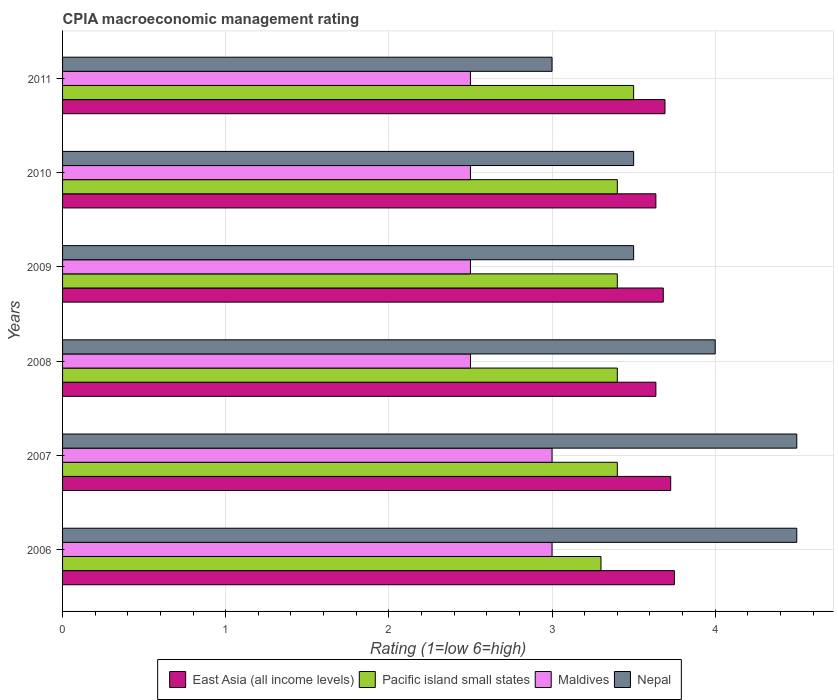How many different coloured bars are there?
Make the answer very short. 4. What is the label of the 4th group of bars from the top?
Provide a short and direct response. 2008. In how many cases, is the number of bars for a given year not equal to the number of legend labels?
Provide a succinct answer. 0. What is the CPIA rating in Nepal in 2008?
Give a very brief answer. 4. Across all years, what is the minimum CPIA rating in East Asia (all income levels)?
Your response must be concise. 3.64. In which year was the CPIA rating in East Asia (all income levels) minimum?
Offer a very short reply. 2008. What is the total CPIA rating in Pacific island small states in the graph?
Keep it short and to the point. 20.4. What is the difference between the CPIA rating in Pacific island small states in 2007 and that in 2008?
Ensure brevity in your answer.  0. What is the difference between the CPIA rating in Pacific island small states in 2009 and the CPIA rating in Maldives in 2008?
Offer a very short reply. 0.9. What is the average CPIA rating in East Asia (all income levels) per year?
Your answer should be compact. 3.69. In the year 2009, what is the difference between the CPIA rating in Nepal and CPIA rating in East Asia (all income levels)?
Your response must be concise. -0.18. In how many years, is the CPIA rating in Maldives greater than 3 ?
Make the answer very short. 0. What is the ratio of the CPIA rating in Nepal in 2008 to that in 2009?
Make the answer very short. 1.14. Is the difference between the CPIA rating in Nepal in 2007 and 2010 greater than the difference between the CPIA rating in East Asia (all income levels) in 2007 and 2010?
Your answer should be very brief. Yes. What is the difference between the highest and the second highest CPIA rating in Nepal?
Your answer should be very brief. 0. In how many years, is the CPIA rating in Maldives greater than the average CPIA rating in Maldives taken over all years?
Offer a terse response. 2. Is the sum of the CPIA rating in Nepal in 2006 and 2007 greater than the maximum CPIA rating in East Asia (all income levels) across all years?
Offer a very short reply. Yes. Is it the case that in every year, the sum of the CPIA rating in Maldives and CPIA rating in Nepal is greater than the sum of CPIA rating in Pacific island small states and CPIA rating in East Asia (all income levels)?
Provide a short and direct response. No. What does the 3rd bar from the top in 2010 represents?
Your answer should be compact. Pacific island small states. What does the 4th bar from the bottom in 2010 represents?
Provide a succinct answer. Nepal. How many bars are there?
Make the answer very short. 24. How many years are there in the graph?
Offer a very short reply. 6. What is the difference between two consecutive major ticks on the X-axis?
Make the answer very short. 1. Are the values on the major ticks of X-axis written in scientific E-notation?
Provide a succinct answer. No. Does the graph contain grids?
Provide a short and direct response. Yes. How are the legend labels stacked?
Keep it short and to the point. Horizontal. What is the title of the graph?
Offer a terse response. CPIA macroeconomic management rating. Does "Montenegro" appear as one of the legend labels in the graph?
Provide a succinct answer. No. What is the label or title of the Y-axis?
Your response must be concise. Years. What is the Rating (1=low 6=high) of East Asia (all income levels) in 2006?
Make the answer very short. 3.75. What is the Rating (1=low 6=high) of Pacific island small states in 2006?
Your answer should be compact. 3.3. What is the Rating (1=low 6=high) in East Asia (all income levels) in 2007?
Offer a terse response. 3.73. What is the Rating (1=low 6=high) in Pacific island small states in 2007?
Give a very brief answer. 3.4. What is the Rating (1=low 6=high) in Maldives in 2007?
Make the answer very short. 3. What is the Rating (1=low 6=high) of East Asia (all income levels) in 2008?
Provide a short and direct response. 3.64. What is the Rating (1=low 6=high) of Pacific island small states in 2008?
Offer a very short reply. 3.4. What is the Rating (1=low 6=high) in Maldives in 2008?
Your answer should be compact. 2.5. What is the Rating (1=low 6=high) of East Asia (all income levels) in 2009?
Give a very brief answer. 3.68. What is the Rating (1=low 6=high) in Pacific island small states in 2009?
Offer a terse response. 3.4. What is the Rating (1=low 6=high) of East Asia (all income levels) in 2010?
Your response must be concise. 3.64. What is the Rating (1=low 6=high) of Pacific island small states in 2010?
Give a very brief answer. 3.4. What is the Rating (1=low 6=high) of Nepal in 2010?
Make the answer very short. 3.5. What is the Rating (1=low 6=high) of East Asia (all income levels) in 2011?
Give a very brief answer. 3.69. What is the Rating (1=low 6=high) in Pacific island small states in 2011?
Ensure brevity in your answer.  3.5. What is the Rating (1=low 6=high) of Nepal in 2011?
Offer a terse response. 3. Across all years, what is the maximum Rating (1=low 6=high) in East Asia (all income levels)?
Your answer should be very brief. 3.75. Across all years, what is the maximum Rating (1=low 6=high) of Maldives?
Provide a short and direct response. 3. Across all years, what is the maximum Rating (1=low 6=high) of Nepal?
Ensure brevity in your answer.  4.5. Across all years, what is the minimum Rating (1=low 6=high) in East Asia (all income levels)?
Ensure brevity in your answer.  3.64. Across all years, what is the minimum Rating (1=low 6=high) of Pacific island small states?
Give a very brief answer. 3.3. Across all years, what is the minimum Rating (1=low 6=high) of Nepal?
Ensure brevity in your answer.  3. What is the total Rating (1=low 6=high) in East Asia (all income levels) in the graph?
Give a very brief answer. 22.12. What is the total Rating (1=low 6=high) in Pacific island small states in the graph?
Offer a very short reply. 20.4. What is the total Rating (1=low 6=high) in Maldives in the graph?
Your response must be concise. 16. What is the total Rating (1=low 6=high) in Nepal in the graph?
Provide a succinct answer. 23. What is the difference between the Rating (1=low 6=high) of East Asia (all income levels) in 2006 and that in 2007?
Keep it short and to the point. 0.02. What is the difference between the Rating (1=low 6=high) in East Asia (all income levels) in 2006 and that in 2008?
Your answer should be very brief. 0.11. What is the difference between the Rating (1=low 6=high) in Maldives in 2006 and that in 2008?
Provide a short and direct response. 0.5. What is the difference between the Rating (1=low 6=high) in East Asia (all income levels) in 2006 and that in 2009?
Make the answer very short. 0.07. What is the difference between the Rating (1=low 6=high) in Nepal in 2006 and that in 2009?
Provide a short and direct response. 1. What is the difference between the Rating (1=low 6=high) of East Asia (all income levels) in 2006 and that in 2010?
Give a very brief answer. 0.11. What is the difference between the Rating (1=low 6=high) in Pacific island small states in 2006 and that in 2010?
Your answer should be very brief. -0.1. What is the difference between the Rating (1=low 6=high) in East Asia (all income levels) in 2006 and that in 2011?
Make the answer very short. 0.06. What is the difference between the Rating (1=low 6=high) in Maldives in 2006 and that in 2011?
Your answer should be very brief. 0.5. What is the difference between the Rating (1=low 6=high) of Nepal in 2006 and that in 2011?
Offer a very short reply. 1.5. What is the difference between the Rating (1=low 6=high) in East Asia (all income levels) in 2007 and that in 2008?
Give a very brief answer. 0.09. What is the difference between the Rating (1=low 6=high) of Pacific island small states in 2007 and that in 2008?
Provide a short and direct response. 0. What is the difference between the Rating (1=low 6=high) in Maldives in 2007 and that in 2008?
Your answer should be compact. 0.5. What is the difference between the Rating (1=low 6=high) in Nepal in 2007 and that in 2008?
Ensure brevity in your answer.  0.5. What is the difference between the Rating (1=low 6=high) of East Asia (all income levels) in 2007 and that in 2009?
Offer a very short reply. 0.05. What is the difference between the Rating (1=low 6=high) in Pacific island small states in 2007 and that in 2009?
Ensure brevity in your answer.  0. What is the difference between the Rating (1=low 6=high) in East Asia (all income levels) in 2007 and that in 2010?
Your response must be concise. 0.09. What is the difference between the Rating (1=low 6=high) in Pacific island small states in 2007 and that in 2010?
Ensure brevity in your answer.  0. What is the difference between the Rating (1=low 6=high) in Nepal in 2007 and that in 2010?
Your answer should be very brief. 1. What is the difference between the Rating (1=low 6=high) in East Asia (all income levels) in 2007 and that in 2011?
Your answer should be compact. 0.04. What is the difference between the Rating (1=low 6=high) in Pacific island small states in 2007 and that in 2011?
Give a very brief answer. -0.1. What is the difference between the Rating (1=low 6=high) of Nepal in 2007 and that in 2011?
Make the answer very short. 1.5. What is the difference between the Rating (1=low 6=high) of East Asia (all income levels) in 2008 and that in 2009?
Provide a succinct answer. -0.05. What is the difference between the Rating (1=low 6=high) in Pacific island small states in 2008 and that in 2009?
Your answer should be compact. 0. What is the difference between the Rating (1=low 6=high) in Nepal in 2008 and that in 2009?
Your answer should be compact. 0.5. What is the difference between the Rating (1=low 6=high) in East Asia (all income levels) in 2008 and that in 2011?
Make the answer very short. -0.06. What is the difference between the Rating (1=low 6=high) of Maldives in 2008 and that in 2011?
Provide a short and direct response. 0. What is the difference between the Rating (1=low 6=high) of Nepal in 2008 and that in 2011?
Offer a very short reply. 1. What is the difference between the Rating (1=low 6=high) in East Asia (all income levels) in 2009 and that in 2010?
Your answer should be compact. 0.05. What is the difference between the Rating (1=low 6=high) of Pacific island small states in 2009 and that in 2010?
Make the answer very short. 0. What is the difference between the Rating (1=low 6=high) of Nepal in 2009 and that in 2010?
Offer a terse response. 0. What is the difference between the Rating (1=low 6=high) in East Asia (all income levels) in 2009 and that in 2011?
Ensure brevity in your answer.  -0.01. What is the difference between the Rating (1=low 6=high) in Pacific island small states in 2009 and that in 2011?
Ensure brevity in your answer.  -0.1. What is the difference between the Rating (1=low 6=high) in East Asia (all income levels) in 2010 and that in 2011?
Provide a short and direct response. -0.06. What is the difference between the Rating (1=low 6=high) in Maldives in 2010 and that in 2011?
Your response must be concise. 0. What is the difference between the Rating (1=low 6=high) of East Asia (all income levels) in 2006 and the Rating (1=low 6=high) of Pacific island small states in 2007?
Provide a short and direct response. 0.35. What is the difference between the Rating (1=low 6=high) of East Asia (all income levels) in 2006 and the Rating (1=low 6=high) of Nepal in 2007?
Provide a short and direct response. -0.75. What is the difference between the Rating (1=low 6=high) of Pacific island small states in 2006 and the Rating (1=low 6=high) of Nepal in 2007?
Your answer should be very brief. -1.2. What is the difference between the Rating (1=low 6=high) in East Asia (all income levels) in 2006 and the Rating (1=low 6=high) in Pacific island small states in 2008?
Make the answer very short. 0.35. What is the difference between the Rating (1=low 6=high) in Pacific island small states in 2006 and the Rating (1=low 6=high) in Nepal in 2008?
Provide a succinct answer. -0.7. What is the difference between the Rating (1=low 6=high) in East Asia (all income levels) in 2006 and the Rating (1=low 6=high) in Maldives in 2009?
Make the answer very short. 1.25. What is the difference between the Rating (1=low 6=high) of East Asia (all income levels) in 2006 and the Rating (1=low 6=high) of Nepal in 2009?
Your answer should be very brief. 0.25. What is the difference between the Rating (1=low 6=high) of Pacific island small states in 2006 and the Rating (1=low 6=high) of Maldives in 2009?
Make the answer very short. 0.8. What is the difference between the Rating (1=low 6=high) in Pacific island small states in 2006 and the Rating (1=low 6=high) in Nepal in 2009?
Provide a short and direct response. -0.2. What is the difference between the Rating (1=low 6=high) of East Asia (all income levels) in 2006 and the Rating (1=low 6=high) of Nepal in 2010?
Offer a very short reply. 0.25. What is the difference between the Rating (1=low 6=high) in Pacific island small states in 2006 and the Rating (1=low 6=high) in Maldives in 2010?
Keep it short and to the point. 0.8. What is the difference between the Rating (1=low 6=high) of Pacific island small states in 2006 and the Rating (1=low 6=high) of Nepal in 2010?
Provide a short and direct response. -0.2. What is the difference between the Rating (1=low 6=high) of Maldives in 2006 and the Rating (1=low 6=high) of Nepal in 2010?
Your response must be concise. -0.5. What is the difference between the Rating (1=low 6=high) of East Asia (all income levels) in 2006 and the Rating (1=low 6=high) of Pacific island small states in 2011?
Your answer should be compact. 0.25. What is the difference between the Rating (1=low 6=high) in Pacific island small states in 2006 and the Rating (1=low 6=high) in Maldives in 2011?
Offer a terse response. 0.8. What is the difference between the Rating (1=low 6=high) of Pacific island small states in 2006 and the Rating (1=low 6=high) of Nepal in 2011?
Ensure brevity in your answer.  0.3. What is the difference between the Rating (1=low 6=high) in Maldives in 2006 and the Rating (1=low 6=high) in Nepal in 2011?
Ensure brevity in your answer.  0. What is the difference between the Rating (1=low 6=high) of East Asia (all income levels) in 2007 and the Rating (1=low 6=high) of Pacific island small states in 2008?
Give a very brief answer. 0.33. What is the difference between the Rating (1=low 6=high) of East Asia (all income levels) in 2007 and the Rating (1=low 6=high) of Maldives in 2008?
Offer a very short reply. 1.23. What is the difference between the Rating (1=low 6=high) in East Asia (all income levels) in 2007 and the Rating (1=low 6=high) in Nepal in 2008?
Your answer should be very brief. -0.27. What is the difference between the Rating (1=low 6=high) in Pacific island small states in 2007 and the Rating (1=low 6=high) in Nepal in 2008?
Provide a short and direct response. -0.6. What is the difference between the Rating (1=low 6=high) in East Asia (all income levels) in 2007 and the Rating (1=low 6=high) in Pacific island small states in 2009?
Provide a short and direct response. 0.33. What is the difference between the Rating (1=low 6=high) in East Asia (all income levels) in 2007 and the Rating (1=low 6=high) in Maldives in 2009?
Your answer should be compact. 1.23. What is the difference between the Rating (1=low 6=high) in East Asia (all income levels) in 2007 and the Rating (1=low 6=high) in Nepal in 2009?
Make the answer very short. 0.23. What is the difference between the Rating (1=low 6=high) in Pacific island small states in 2007 and the Rating (1=low 6=high) in Nepal in 2009?
Provide a succinct answer. -0.1. What is the difference between the Rating (1=low 6=high) in Maldives in 2007 and the Rating (1=low 6=high) in Nepal in 2009?
Provide a short and direct response. -0.5. What is the difference between the Rating (1=low 6=high) of East Asia (all income levels) in 2007 and the Rating (1=low 6=high) of Pacific island small states in 2010?
Keep it short and to the point. 0.33. What is the difference between the Rating (1=low 6=high) of East Asia (all income levels) in 2007 and the Rating (1=low 6=high) of Maldives in 2010?
Offer a terse response. 1.23. What is the difference between the Rating (1=low 6=high) of East Asia (all income levels) in 2007 and the Rating (1=low 6=high) of Nepal in 2010?
Make the answer very short. 0.23. What is the difference between the Rating (1=low 6=high) in Pacific island small states in 2007 and the Rating (1=low 6=high) in Maldives in 2010?
Provide a short and direct response. 0.9. What is the difference between the Rating (1=low 6=high) in Pacific island small states in 2007 and the Rating (1=low 6=high) in Nepal in 2010?
Your answer should be very brief. -0.1. What is the difference between the Rating (1=low 6=high) of Maldives in 2007 and the Rating (1=low 6=high) of Nepal in 2010?
Make the answer very short. -0.5. What is the difference between the Rating (1=low 6=high) in East Asia (all income levels) in 2007 and the Rating (1=low 6=high) in Pacific island small states in 2011?
Ensure brevity in your answer.  0.23. What is the difference between the Rating (1=low 6=high) in East Asia (all income levels) in 2007 and the Rating (1=low 6=high) in Maldives in 2011?
Offer a very short reply. 1.23. What is the difference between the Rating (1=low 6=high) of East Asia (all income levels) in 2007 and the Rating (1=low 6=high) of Nepal in 2011?
Your answer should be very brief. 0.73. What is the difference between the Rating (1=low 6=high) in Pacific island small states in 2007 and the Rating (1=low 6=high) in Maldives in 2011?
Offer a very short reply. 0.9. What is the difference between the Rating (1=low 6=high) of Maldives in 2007 and the Rating (1=low 6=high) of Nepal in 2011?
Offer a terse response. 0. What is the difference between the Rating (1=low 6=high) in East Asia (all income levels) in 2008 and the Rating (1=low 6=high) in Pacific island small states in 2009?
Your answer should be compact. 0.24. What is the difference between the Rating (1=low 6=high) of East Asia (all income levels) in 2008 and the Rating (1=low 6=high) of Maldives in 2009?
Keep it short and to the point. 1.14. What is the difference between the Rating (1=low 6=high) of East Asia (all income levels) in 2008 and the Rating (1=low 6=high) of Nepal in 2009?
Offer a very short reply. 0.14. What is the difference between the Rating (1=low 6=high) of Pacific island small states in 2008 and the Rating (1=low 6=high) of Nepal in 2009?
Your answer should be very brief. -0.1. What is the difference between the Rating (1=low 6=high) of East Asia (all income levels) in 2008 and the Rating (1=low 6=high) of Pacific island small states in 2010?
Make the answer very short. 0.24. What is the difference between the Rating (1=low 6=high) of East Asia (all income levels) in 2008 and the Rating (1=low 6=high) of Maldives in 2010?
Offer a very short reply. 1.14. What is the difference between the Rating (1=low 6=high) of East Asia (all income levels) in 2008 and the Rating (1=low 6=high) of Nepal in 2010?
Keep it short and to the point. 0.14. What is the difference between the Rating (1=low 6=high) in Pacific island small states in 2008 and the Rating (1=low 6=high) in Nepal in 2010?
Offer a very short reply. -0.1. What is the difference between the Rating (1=low 6=high) in East Asia (all income levels) in 2008 and the Rating (1=low 6=high) in Pacific island small states in 2011?
Make the answer very short. 0.14. What is the difference between the Rating (1=low 6=high) of East Asia (all income levels) in 2008 and the Rating (1=low 6=high) of Maldives in 2011?
Provide a succinct answer. 1.14. What is the difference between the Rating (1=low 6=high) of East Asia (all income levels) in 2008 and the Rating (1=low 6=high) of Nepal in 2011?
Keep it short and to the point. 0.64. What is the difference between the Rating (1=low 6=high) in East Asia (all income levels) in 2009 and the Rating (1=low 6=high) in Pacific island small states in 2010?
Your answer should be very brief. 0.28. What is the difference between the Rating (1=low 6=high) in East Asia (all income levels) in 2009 and the Rating (1=low 6=high) in Maldives in 2010?
Provide a short and direct response. 1.18. What is the difference between the Rating (1=low 6=high) in East Asia (all income levels) in 2009 and the Rating (1=low 6=high) in Nepal in 2010?
Keep it short and to the point. 0.18. What is the difference between the Rating (1=low 6=high) in Maldives in 2009 and the Rating (1=low 6=high) in Nepal in 2010?
Your response must be concise. -1. What is the difference between the Rating (1=low 6=high) in East Asia (all income levels) in 2009 and the Rating (1=low 6=high) in Pacific island small states in 2011?
Make the answer very short. 0.18. What is the difference between the Rating (1=low 6=high) in East Asia (all income levels) in 2009 and the Rating (1=low 6=high) in Maldives in 2011?
Your answer should be very brief. 1.18. What is the difference between the Rating (1=low 6=high) of East Asia (all income levels) in 2009 and the Rating (1=low 6=high) of Nepal in 2011?
Offer a very short reply. 0.68. What is the difference between the Rating (1=low 6=high) in Pacific island small states in 2009 and the Rating (1=low 6=high) in Maldives in 2011?
Your answer should be very brief. 0.9. What is the difference between the Rating (1=low 6=high) in Pacific island small states in 2009 and the Rating (1=low 6=high) in Nepal in 2011?
Provide a succinct answer. 0.4. What is the difference between the Rating (1=low 6=high) in East Asia (all income levels) in 2010 and the Rating (1=low 6=high) in Pacific island small states in 2011?
Ensure brevity in your answer.  0.14. What is the difference between the Rating (1=low 6=high) in East Asia (all income levels) in 2010 and the Rating (1=low 6=high) in Maldives in 2011?
Your response must be concise. 1.14. What is the difference between the Rating (1=low 6=high) of East Asia (all income levels) in 2010 and the Rating (1=low 6=high) of Nepal in 2011?
Provide a short and direct response. 0.64. What is the difference between the Rating (1=low 6=high) in Maldives in 2010 and the Rating (1=low 6=high) in Nepal in 2011?
Provide a succinct answer. -0.5. What is the average Rating (1=low 6=high) of East Asia (all income levels) per year?
Make the answer very short. 3.69. What is the average Rating (1=low 6=high) of Pacific island small states per year?
Keep it short and to the point. 3.4. What is the average Rating (1=low 6=high) in Maldives per year?
Make the answer very short. 2.67. What is the average Rating (1=low 6=high) in Nepal per year?
Your answer should be very brief. 3.83. In the year 2006, what is the difference between the Rating (1=low 6=high) in East Asia (all income levels) and Rating (1=low 6=high) in Pacific island small states?
Ensure brevity in your answer.  0.45. In the year 2006, what is the difference between the Rating (1=low 6=high) of East Asia (all income levels) and Rating (1=low 6=high) of Maldives?
Offer a terse response. 0.75. In the year 2006, what is the difference between the Rating (1=low 6=high) in East Asia (all income levels) and Rating (1=low 6=high) in Nepal?
Give a very brief answer. -0.75. In the year 2006, what is the difference between the Rating (1=low 6=high) in Maldives and Rating (1=low 6=high) in Nepal?
Your response must be concise. -1.5. In the year 2007, what is the difference between the Rating (1=low 6=high) of East Asia (all income levels) and Rating (1=low 6=high) of Pacific island small states?
Provide a succinct answer. 0.33. In the year 2007, what is the difference between the Rating (1=low 6=high) in East Asia (all income levels) and Rating (1=low 6=high) in Maldives?
Give a very brief answer. 0.73. In the year 2007, what is the difference between the Rating (1=low 6=high) in East Asia (all income levels) and Rating (1=low 6=high) in Nepal?
Make the answer very short. -0.77. In the year 2007, what is the difference between the Rating (1=low 6=high) of Pacific island small states and Rating (1=low 6=high) of Maldives?
Your answer should be very brief. 0.4. In the year 2007, what is the difference between the Rating (1=low 6=high) in Maldives and Rating (1=low 6=high) in Nepal?
Offer a terse response. -1.5. In the year 2008, what is the difference between the Rating (1=low 6=high) of East Asia (all income levels) and Rating (1=low 6=high) of Pacific island small states?
Keep it short and to the point. 0.24. In the year 2008, what is the difference between the Rating (1=low 6=high) in East Asia (all income levels) and Rating (1=low 6=high) in Maldives?
Provide a short and direct response. 1.14. In the year 2008, what is the difference between the Rating (1=low 6=high) of East Asia (all income levels) and Rating (1=low 6=high) of Nepal?
Make the answer very short. -0.36. In the year 2008, what is the difference between the Rating (1=low 6=high) of Pacific island small states and Rating (1=low 6=high) of Maldives?
Offer a terse response. 0.9. In the year 2009, what is the difference between the Rating (1=low 6=high) in East Asia (all income levels) and Rating (1=low 6=high) in Pacific island small states?
Offer a very short reply. 0.28. In the year 2009, what is the difference between the Rating (1=low 6=high) in East Asia (all income levels) and Rating (1=low 6=high) in Maldives?
Your answer should be very brief. 1.18. In the year 2009, what is the difference between the Rating (1=low 6=high) of East Asia (all income levels) and Rating (1=low 6=high) of Nepal?
Provide a succinct answer. 0.18. In the year 2010, what is the difference between the Rating (1=low 6=high) of East Asia (all income levels) and Rating (1=low 6=high) of Pacific island small states?
Your answer should be compact. 0.24. In the year 2010, what is the difference between the Rating (1=low 6=high) in East Asia (all income levels) and Rating (1=low 6=high) in Maldives?
Offer a very short reply. 1.14. In the year 2010, what is the difference between the Rating (1=low 6=high) in East Asia (all income levels) and Rating (1=low 6=high) in Nepal?
Give a very brief answer. 0.14. In the year 2011, what is the difference between the Rating (1=low 6=high) of East Asia (all income levels) and Rating (1=low 6=high) of Pacific island small states?
Keep it short and to the point. 0.19. In the year 2011, what is the difference between the Rating (1=low 6=high) in East Asia (all income levels) and Rating (1=low 6=high) in Maldives?
Keep it short and to the point. 1.19. In the year 2011, what is the difference between the Rating (1=low 6=high) in East Asia (all income levels) and Rating (1=low 6=high) in Nepal?
Your answer should be very brief. 0.69. In the year 2011, what is the difference between the Rating (1=low 6=high) in Pacific island small states and Rating (1=low 6=high) in Maldives?
Your answer should be very brief. 1. In the year 2011, what is the difference between the Rating (1=low 6=high) of Pacific island small states and Rating (1=low 6=high) of Nepal?
Provide a short and direct response. 0.5. What is the ratio of the Rating (1=low 6=high) in Pacific island small states in 2006 to that in 2007?
Offer a terse response. 0.97. What is the ratio of the Rating (1=low 6=high) of Nepal in 2006 to that in 2007?
Make the answer very short. 1. What is the ratio of the Rating (1=low 6=high) of East Asia (all income levels) in 2006 to that in 2008?
Offer a very short reply. 1.03. What is the ratio of the Rating (1=low 6=high) of Pacific island small states in 2006 to that in 2008?
Offer a very short reply. 0.97. What is the ratio of the Rating (1=low 6=high) in Maldives in 2006 to that in 2008?
Offer a terse response. 1.2. What is the ratio of the Rating (1=low 6=high) of East Asia (all income levels) in 2006 to that in 2009?
Offer a terse response. 1.02. What is the ratio of the Rating (1=low 6=high) of Pacific island small states in 2006 to that in 2009?
Your answer should be very brief. 0.97. What is the ratio of the Rating (1=low 6=high) in Maldives in 2006 to that in 2009?
Your answer should be very brief. 1.2. What is the ratio of the Rating (1=low 6=high) in East Asia (all income levels) in 2006 to that in 2010?
Ensure brevity in your answer.  1.03. What is the ratio of the Rating (1=low 6=high) in Pacific island small states in 2006 to that in 2010?
Provide a short and direct response. 0.97. What is the ratio of the Rating (1=low 6=high) in East Asia (all income levels) in 2006 to that in 2011?
Provide a short and direct response. 1.02. What is the ratio of the Rating (1=low 6=high) of Pacific island small states in 2006 to that in 2011?
Your answer should be compact. 0.94. What is the ratio of the Rating (1=low 6=high) of Maldives in 2007 to that in 2008?
Keep it short and to the point. 1.2. What is the ratio of the Rating (1=low 6=high) of Nepal in 2007 to that in 2008?
Ensure brevity in your answer.  1.12. What is the ratio of the Rating (1=low 6=high) of East Asia (all income levels) in 2007 to that in 2009?
Make the answer very short. 1.01. What is the ratio of the Rating (1=low 6=high) in Pacific island small states in 2007 to that in 2009?
Your answer should be very brief. 1. What is the ratio of the Rating (1=low 6=high) in Nepal in 2007 to that in 2009?
Offer a very short reply. 1.29. What is the ratio of the Rating (1=low 6=high) of Pacific island small states in 2007 to that in 2010?
Keep it short and to the point. 1. What is the ratio of the Rating (1=low 6=high) of Maldives in 2007 to that in 2010?
Ensure brevity in your answer.  1.2. What is the ratio of the Rating (1=low 6=high) in East Asia (all income levels) in 2007 to that in 2011?
Make the answer very short. 1.01. What is the ratio of the Rating (1=low 6=high) in Pacific island small states in 2007 to that in 2011?
Offer a terse response. 0.97. What is the ratio of the Rating (1=low 6=high) of Nepal in 2007 to that in 2011?
Your answer should be compact. 1.5. What is the ratio of the Rating (1=low 6=high) in Pacific island small states in 2008 to that in 2009?
Provide a short and direct response. 1. What is the ratio of the Rating (1=low 6=high) in Pacific island small states in 2008 to that in 2010?
Provide a succinct answer. 1. What is the ratio of the Rating (1=low 6=high) of Nepal in 2008 to that in 2010?
Your answer should be compact. 1.14. What is the ratio of the Rating (1=low 6=high) in East Asia (all income levels) in 2008 to that in 2011?
Provide a succinct answer. 0.98. What is the ratio of the Rating (1=low 6=high) of Pacific island small states in 2008 to that in 2011?
Provide a succinct answer. 0.97. What is the ratio of the Rating (1=low 6=high) in Nepal in 2008 to that in 2011?
Provide a short and direct response. 1.33. What is the ratio of the Rating (1=low 6=high) of East Asia (all income levels) in 2009 to that in 2010?
Offer a very short reply. 1.01. What is the ratio of the Rating (1=low 6=high) of Pacific island small states in 2009 to that in 2010?
Provide a short and direct response. 1. What is the ratio of the Rating (1=low 6=high) of East Asia (all income levels) in 2009 to that in 2011?
Make the answer very short. 1. What is the ratio of the Rating (1=low 6=high) in Pacific island small states in 2009 to that in 2011?
Offer a very short reply. 0.97. What is the ratio of the Rating (1=low 6=high) in Maldives in 2009 to that in 2011?
Ensure brevity in your answer.  1. What is the ratio of the Rating (1=low 6=high) of East Asia (all income levels) in 2010 to that in 2011?
Give a very brief answer. 0.98. What is the ratio of the Rating (1=low 6=high) in Pacific island small states in 2010 to that in 2011?
Keep it short and to the point. 0.97. What is the ratio of the Rating (1=low 6=high) in Maldives in 2010 to that in 2011?
Offer a terse response. 1. What is the difference between the highest and the second highest Rating (1=low 6=high) of East Asia (all income levels)?
Provide a short and direct response. 0.02. What is the difference between the highest and the second highest Rating (1=low 6=high) in Maldives?
Your answer should be very brief. 0. What is the difference between the highest and the lowest Rating (1=low 6=high) of East Asia (all income levels)?
Provide a short and direct response. 0.11. What is the difference between the highest and the lowest Rating (1=low 6=high) in Pacific island small states?
Give a very brief answer. 0.2. What is the difference between the highest and the lowest Rating (1=low 6=high) of Maldives?
Your response must be concise. 0.5. What is the difference between the highest and the lowest Rating (1=low 6=high) in Nepal?
Offer a terse response. 1.5. 